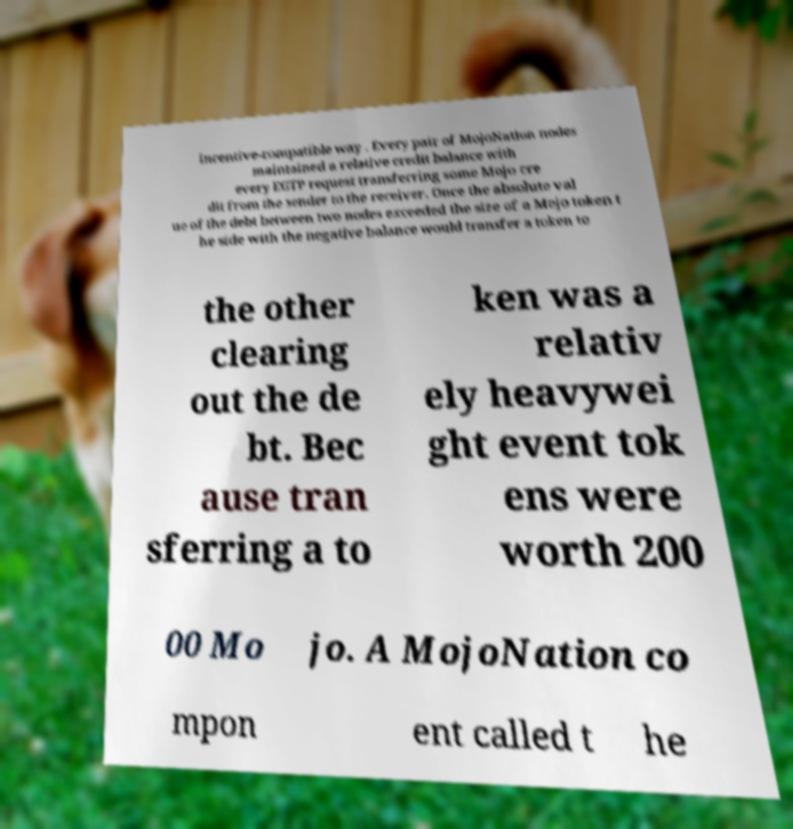Please identify and transcribe the text found in this image. incentive-compatible way . Every pair of MojoNation nodes maintained a relative credit balance with every EGTP request transferring some Mojo cre dit from the sender to the receiver. Once the absolute val ue of the debt between two nodes exceeded the size of a Mojo token t he side with the negative balance would transfer a token to the other clearing out the de bt. Bec ause tran sferring a to ken was a relativ ely heavywei ght event tok ens were worth 200 00 Mo jo. A MojoNation co mpon ent called t he 